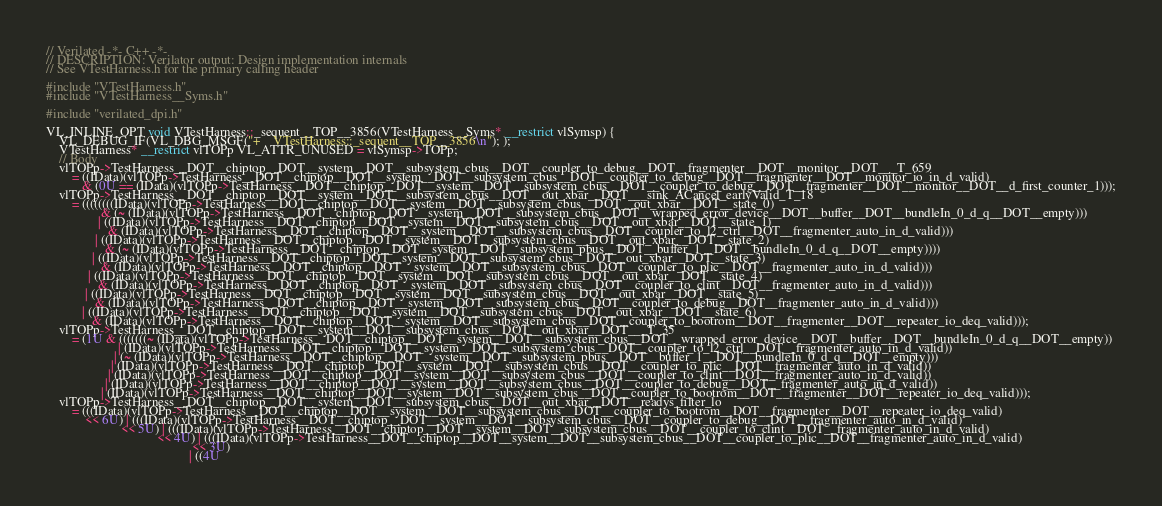Convert code to text. <code><loc_0><loc_0><loc_500><loc_500><_C++_>// Verilated -*- C++ -*-
// DESCRIPTION: Verilator output: Design implementation internals
// See VTestHarness.h for the primary calling header

#include "VTestHarness.h"
#include "VTestHarness__Syms.h"

#include "verilated_dpi.h"

VL_INLINE_OPT void VTestHarness::_sequent__TOP__3856(VTestHarness__Syms* __restrict vlSymsp) {
    VL_DEBUG_IF(VL_DBG_MSGF("+    VTestHarness::_sequent__TOP__3856\n"); );
    VTestHarness* __restrict vlTOPp VL_ATTR_UNUSED = vlSymsp->TOPp;
    // Body
    vlTOPp->TestHarness__DOT__chiptop__DOT__system__DOT__subsystem_cbus__DOT__coupler_to_debug__DOT__fragmenter__DOT__monitor__DOT___T_659 
        = ((IData)(vlTOPp->TestHarness__DOT__chiptop__DOT__system__DOT__subsystem_cbus__DOT__coupler_to_debug__DOT__fragmenter__DOT__monitor_io_in_d_valid) 
           & (0U == (IData)(vlTOPp->TestHarness__DOT__chiptop__DOT__system__DOT__subsystem_cbus__DOT__coupler_to_debug__DOT__fragmenter__DOT__monitor__DOT__d_first_counter_1)));
    vlTOPp->TestHarness__DOT__chiptop__DOT__system__DOT__subsystem_cbus__DOT__out_xbar__DOT___sink_ACancel_earlyValid_T_18 
        = ((((((((IData)(vlTOPp->TestHarness__DOT__chiptop__DOT__system__DOT__subsystem_cbus__DOT__out_xbar__DOT__state_0) 
                 & (~ (IData)(vlTOPp->TestHarness__DOT__chiptop__DOT__system__DOT__subsystem_cbus__DOT__wrapped_error_device__DOT__buffer__DOT__bundleIn_0_d_q__DOT__empty))) 
                | ((IData)(vlTOPp->TestHarness__DOT__chiptop__DOT__system__DOT__subsystem_cbus__DOT__out_xbar__DOT__state_1) 
                   & (IData)(vlTOPp->TestHarness__DOT__chiptop__DOT__system__DOT__subsystem_cbus__DOT__coupler_to_l2_ctrl__DOT__fragmenter_auto_in_d_valid))) 
               | ((IData)(vlTOPp->TestHarness__DOT__chiptop__DOT__system__DOT__subsystem_cbus__DOT__out_xbar__DOT__state_2) 
                  & (~ (IData)(vlTOPp->TestHarness__DOT__chiptop__DOT__system__DOT__subsystem_pbus__DOT__buffer_1__DOT__bundleIn_0_d_q__DOT__empty)))) 
              | ((IData)(vlTOPp->TestHarness__DOT__chiptop__DOT__system__DOT__subsystem_cbus__DOT__out_xbar__DOT__state_3) 
                 & (IData)(vlTOPp->TestHarness__DOT__chiptop__DOT__system__DOT__subsystem_cbus__DOT__coupler_to_plic__DOT__fragmenter_auto_in_d_valid))) 
             | ((IData)(vlTOPp->TestHarness__DOT__chiptop__DOT__system__DOT__subsystem_cbus__DOT__out_xbar__DOT__state_4) 
                & (IData)(vlTOPp->TestHarness__DOT__chiptop__DOT__system__DOT__subsystem_cbus__DOT__coupler_to_clint__DOT__fragmenter_auto_in_d_valid))) 
            | ((IData)(vlTOPp->TestHarness__DOT__chiptop__DOT__system__DOT__subsystem_cbus__DOT__out_xbar__DOT__state_5) 
               & (IData)(vlTOPp->TestHarness__DOT__chiptop__DOT__system__DOT__subsystem_cbus__DOT__coupler_to_debug__DOT__fragmenter_auto_in_d_valid))) 
           | ((IData)(vlTOPp->TestHarness__DOT__chiptop__DOT__system__DOT__subsystem_cbus__DOT__out_xbar__DOT__state_6) 
              & (IData)(vlTOPp->TestHarness__DOT__chiptop__DOT__system__DOT__subsystem_cbus__DOT__coupler_to_bootrom__DOT__fragmenter__DOT__repeater_io_deq_valid)));
    vlTOPp->TestHarness__DOT__chiptop__DOT__system__DOT__subsystem_cbus__DOT__out_xbar__DOT___T_35 
        = (1U & (((((((~ (IData)(vlTOPp->TestHarness__DOT__chiptop__DOT__system__DOT__subsystem_cbus__DOT__wrapped_error_device__DOT__buffer__DOT__bundleIn_0_d_q__DOT__empty)) 
                      | (IData)(vlTOPp->TestHarness__DOT__chiptop__DOT__system__DOT__subsystem_cbus__DOT__coupler_to_l2_ctrl__DOT__fragmenter_auto_in_d_valid)) 
                     | (~ (IData)(vlTOPp->TestHarness__DOT__chiptop__DOT__system__DOT__subsystem_pbus__DOT__buffer_1__DOT__bundleIn_0_d_q__DOT__empty))) 
                    | (IData)(vlTOPp->TestHarness__DOT__chiptop__DOT__system__DOT__subsystem_cbus__DOT__coupler_to_plic__DOT__fragmenter_auto_in_d_valid)) 
                   | (IData)(vlTOPp->TestHarness__DOT__chiptop__DOT__system__DOT__subsystem_cbus__DOT__coupler_to_clint__DOT__fragmenter_auto_in_d_valid)) 
                  | (IData)(vlTOPp->TestHarness__DOT__chiptop__DOT__system__DOT__subsystem_cbus__DOT__coupler_to_debug__DOT__fragmenter_auto_in_d_valid)) 
                 | (IData)(vlTOPp->TestHarness__DOT__chiptop__DOT__system__DOT__subsystem_cbus__DOT__coupler_to_bootrom__DOT__fragmenter__DOT__repeater_io_deq_valid)));
    vlTOPp->TestHarness__DOT__chiptop__DOT__system__DOT__subsystem_cbus__DOT__out_xbar__DOT__readys_filter_lo 
        = (((IData)(vlTOPp->TestHarness__DOT__chiptop__DOT__system__DOT__subsystem_cbus__DOT__coupler_to_bootrom__DOT__fragmenter__DOT__repeater_io_deq_valid) 
            << 6U) | (((IData)(vlTOPp->TestHarness__DOT__chiptop__DOT__system__DOT__subsystem_cbus__DOT__coupler_to_debug__DOT__fragmenter_auto_in_d_valid) 
                       << 5U) | (((IData)(vlTOPp->TestHarness__DOT__chiptop__DOT__system__DOT__subsystem_cbus__DOT__coupler_to_clint__DOT__fragmenter_auto_in_d_valid) 
                                  << 4U) | (((IData)(vlTOPp->TestHarness__DOT__chiptop__DOT__system__DOT__subsystem_cbus__DOT__coupler_to_plic__DOT__fragmenter_auto_in_d_valid) 
                                             << 3U) 
                                            | ((4U </code> 